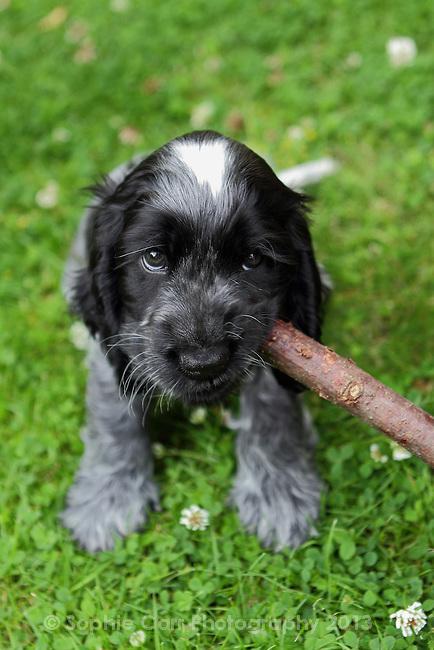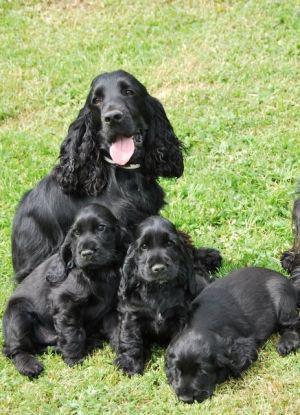The first image is the image on the left, the second image is the image on the right. Given the left and right images, does the statement "The dog on the left has its tongue out." hold true? Answer yes or no. No. The first image is the image on the left, the second image is the image on the right. For the images shown, is this caption "One dog is sitting with its tongue hanging out." true? Answer yes or no. Yes. 